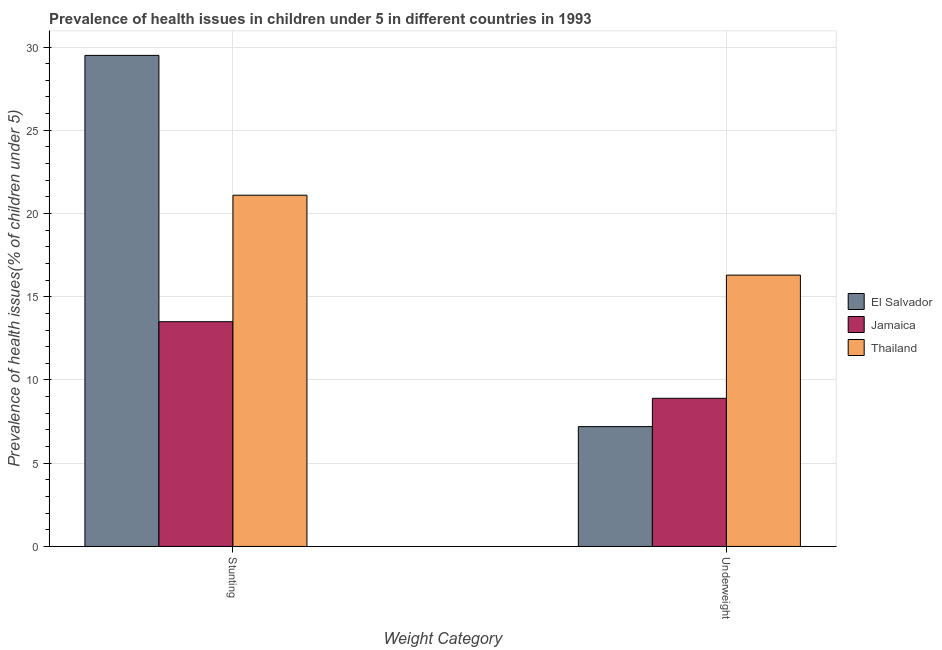How many groups of bars are there?
Your response must be concise. 2. Are the number of bars on each tick of the X-axis equal?
Keep it short and to the point. Yes. How many bars are there on the 1st tick from the right?
Keep it short and to the point. 3. What is the label of the 1st group of bars from the left?
Offer a terse response. Stunting. Across all countries, what is the maximum percentage of underweight children?
Ensure brevity in your answer.  16.3. Across all countries, what is the minimum percentage of underweight children?
Your answer should be very brief. 7.2. In which country was the percentage of stunted children maximum?
Your answer should be very brief. El Salvador. In which country was the percentage of stunted children minimum?
Ensure brevity in your answer.  Jamaica. What is the total percentage of underweight children in the graph?
Offer a terse response. 32.4. What is the difference between the percentage of underweight children in Jamaica and that in El Salvador?
Offer a terse response. 1.7. What is the difference between the percentage of underweight children in Thailand and the percentage of stunted children in El Salvador?
Provide a short and direct response. -13.2. What is the average percentage of stunted children per country?
Provide a short and direct response. 21.37. What is the difference between the percentage of underweight children and percentage of stunted children in Thailand?
Ensure brevity in your answer.  -4.8. What is the ratio of the percentage of stunted children in El Salvador to that in Thailand?
Offer a very short reply. 1.4. Is the percentage of underweight children in El Salvador less than that in Thailand?
Your answer should be compact. Yes. In how many countries, is the percentage of underweight children greater than the average percentage of underweight children taken over all countries?
Your answer should be very brief. 1. What does the 1st bar from the left in Underweight represents?
Your answer should be very brief. El Salvador. What does the 2nd bar from the right in Stunting represents?
Offer a terse response. Jamaica. Are all the bars in the graph horizontal?
Make the answer very short. No. How many countries are there in the graph?
Ensure brevity in your answer.  3. What is the difference between two consecutive major ticks on the Y-axis?
Offer a very short reply. 5. Does the graph contain grids?
Offer a very short reply. Yes. How many legend labels are there?
Offer a terse response. 3. How are the legend labels stacked?
Make the answer very short. Vertical. What is the title of the graph?
Your response must be concise. Prevalence of health issues in children under 5 in different countries in 1993. What is the label or title of the X-axis?
Make the answer very short. Weight Category. What is the label or title of the Y-axis?
Provide a succinct answer. Prevalence of health issues(% of children under 5). What is the Prevalence of health issues(% of children under 5) in El Salvador in Stunting?
Provide a short and direct response. 29.5. What is the Prevalence of health issues(% of children under 5) in Thailand in Stunting?
Offer a terse response. 21.1. What is the Prevalence of health issues(% of children under 5) in El Salvador in Underweight?
Ensure brevity in your answer.  7.2. What is the Prevalence of health issues(% of children under 5) of Jamaica in Underweight?
Give a very brief answer. 8.9. What is the Prevalence of health issues(% of children under 5) of Thailand in Underweight?
Ensure brevity in your answer.  16.3. Across all Weight Category, what is the maximum Prevalence of health issues(% of children under 5) in El Salvador?
Ensure brevity in your answer.  29.5. Across all Weight Category, what is the maximum Prevalence of health issues(% of children under 5) in Thailand?
Offer a very short reply. 21.1. Across all Weight Category, what is the minimum Prevalence of health issues(% of children under 5) of El Salvador?
Make the answer very short. 7.2. Across all Weight Category, what is the minimum Prevalence of health issues(% of children under 5) of Jamaica?
Provide a succinct answer. 8.9. Across all Weight Category, what is the minimum Prevalence of health issues(% of children under 5) in Thailand?
Your answer should be very brief. 16.3. What is the total Prevalence of health issues(% of children under 5) of El Salvador in the graph?
Offer a terse response. 36.7. What is the total Prevalence of health issues(% of children under 5) of Jamaica in the graph?
Offer a very short reply. 22.4. What is the total Prevalence of health issues(% of children under 5) in Thailand in the graph?
Provide a succinct answer. 37.4. What is the difference between the Prevalence of health issues(% of children under 5) in El Salvador in Stunting and that in Underweight?
Your answer should be compact. 22.3. What is the difference between the Prevalence of health issues(% of children under 5) in Jamaica in Stunting and that in Underweight?
Offer a terse response. 4.6. What is the difference between the Prevalence of health issues(% of children under 5) of El Salvador in Stunting and the Prevalence of health issues(% of children under 5) of Jamaica in Underweight?
Your answer should be compact. 20.6. What is the difference between the Prevalence of health issues(% of children under 5) of El Salvador in Stunting and the Prevalence of health issues(% of children under 5) of Thailand in Underweight?
Make the answer very short. 13.2. What is the difference between the Prevalence of health issues(% of children under 5) in Jamaica in Stunting and the Prevalence of health issues(% of children under 5) in Thailand in Underweight?
Your answer should be very brief. -2.8. What is the average Prevalence of health issues(% of children under 5) of El Salvador per Weight Category?
Your response must be concise. 18.35. What is the average Prevalence of health issues(% of children under 5) in Jamaica per Weight Category?
Make the answer very short. 11.2. What is the difference between the Prevalence of health issues(% of children under 5) of El Salvador and Prevalence of health issues(% of children under 5) of Jamaica in Stunting?
Ensure brevity in your answer.  16. What is the difference between the Prevalence of health issues(% of children under 5) in El Salvador and Prevalence of health issues(% of children under 5) in Jamaica in Underweight?
Your response must be concise. -1.7. What is the ratio of the Prevalence of health issues(% of children under 5) in El Salvador in Stunting to that in Underweight?
Make the answer very short. 4.1. What is the ratio of the Prevalence of health issues(% of children under 5) in Jamaica in Stunting to that in Underweight?
Offer a very short reply. 1.52. What is the ratio of the Prevalence of health issues(% of children under 5) in Thailand in Stunting to that in Underweight?
Provide a short and direct response. 1.29. What is the difference between the highest and the second highest Prevalence of health issues(% of children under 5) in El Salvador?
Offer a very short reply. 22.3. What is the difference between the highest and the second highest Prevalence of health issues(% of children under 5) of Thailand?
Provide a short and direct response. 4.8. What is the difference between the highest and the lowest Prevalence of health issues(% of children under 5) in El Salvador?
Your answer should be compact. 22.3. What is the difference between the highest and the lowest Prevalence of health issues(% of children under 5) of Jamaica?
Your answer should be compact. 4.6. 